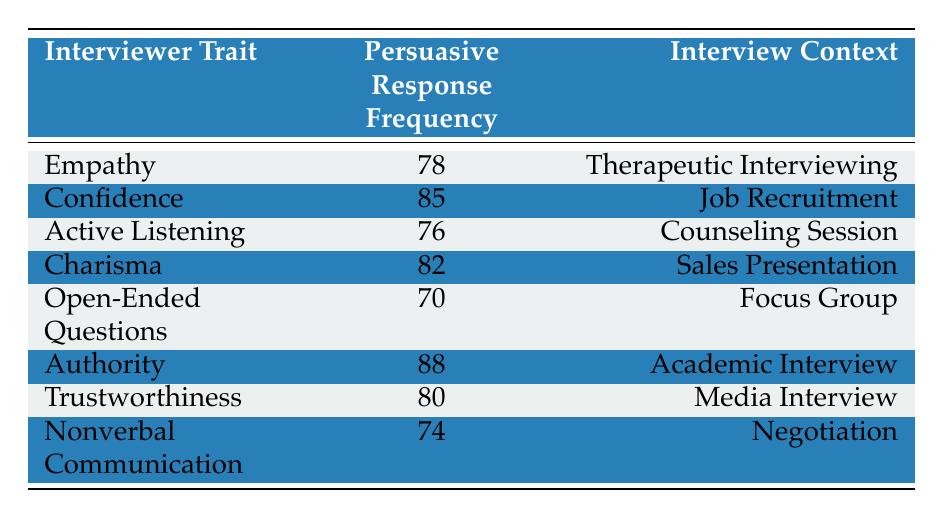What is the persuasive response frequency for the interviewer trait "Charisma"? The table lists "Charisma" under the "Interviewer Trait" column with a corresponding frequency of 82 in the "Persuasive Response Frequency" column.
Answer: 82 Which interviewer trait has the highest persuasive response frequency? By examining the "Persuasive Response Frequency" column, "Authority" is noted as having the highest value, which is 88.
Answer: Authority How many traits have a persuasive response frequency of 80 or above? The relevant frequencies are Authority (88), Confidence (85), Charisma (82), and Trustworthiness (80). Counting these, there are four traits.
Answer: 4 What is the average persuasive response frequency for the listed traits? To find the average, we first add the frequencies: 78 + 85 + 76 + 82 + 70 + 88 + 80 + 74 = 613. There are 8 traits, so the average is 613 divided by 8, which equals 76.625.
Answer: 76.625 Is it true that "Open-Ended Questions" has a persuasive response frequency below 75? The table shows that "Open-Ended Questions" has a frequency of 70, which is indeed below 75, confirming the statement is true.
Answer: Yes Which interviewing context has the lowest persuasive response frequency, and what is that frequency? From the table, the lowest frequency is associated with "Open-Ended Questions," which occurs in a Focus Group context, and this frequency is 70.
Answer: Focus Group, 70 If we compare "Empathy" and "Active Listening," which trait has a greater persuasive response frequency? "Empathy" shows a frequency of 78 and "Active Listening" shows a frequency of 76. Since 78 is greater than 76, "Empathy" has the higher frequency.
Answer: Empathy How does the persuasive response frequency of "Nonverbal Communication" compare to the frequency of "Therapeutic Interviewing"? The frequency for "Nonverbal Communication" is 74 and “Therapeutic Interviewing” is 78; therefore, 74 is less than 78.
Answer: Nonverbal Communication is less than Therapeutic Interviewing 